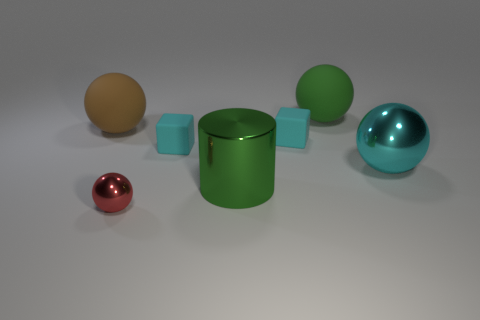Subtract all green matte balls. How many balls are left? 3 Add 2 large green shiny things. How many objects exist? 9 Subtract all brown spheres. How many spheres are left? 3 Subtract all balls. How many objects are left? 3 Subtract all brown blocks. Subtract all cyan cylinders. How many blocks are left? 2 Subtract all tiny red matte blocks. Subtract all big green metallic cylinders. How many objects are left? 6 Add 6 green balls. How many green balls are left? 7 Add 7 green rubber things. How many green rubber things exist? 8 Subtract 0 brown blocks. How many objects are left? 7 